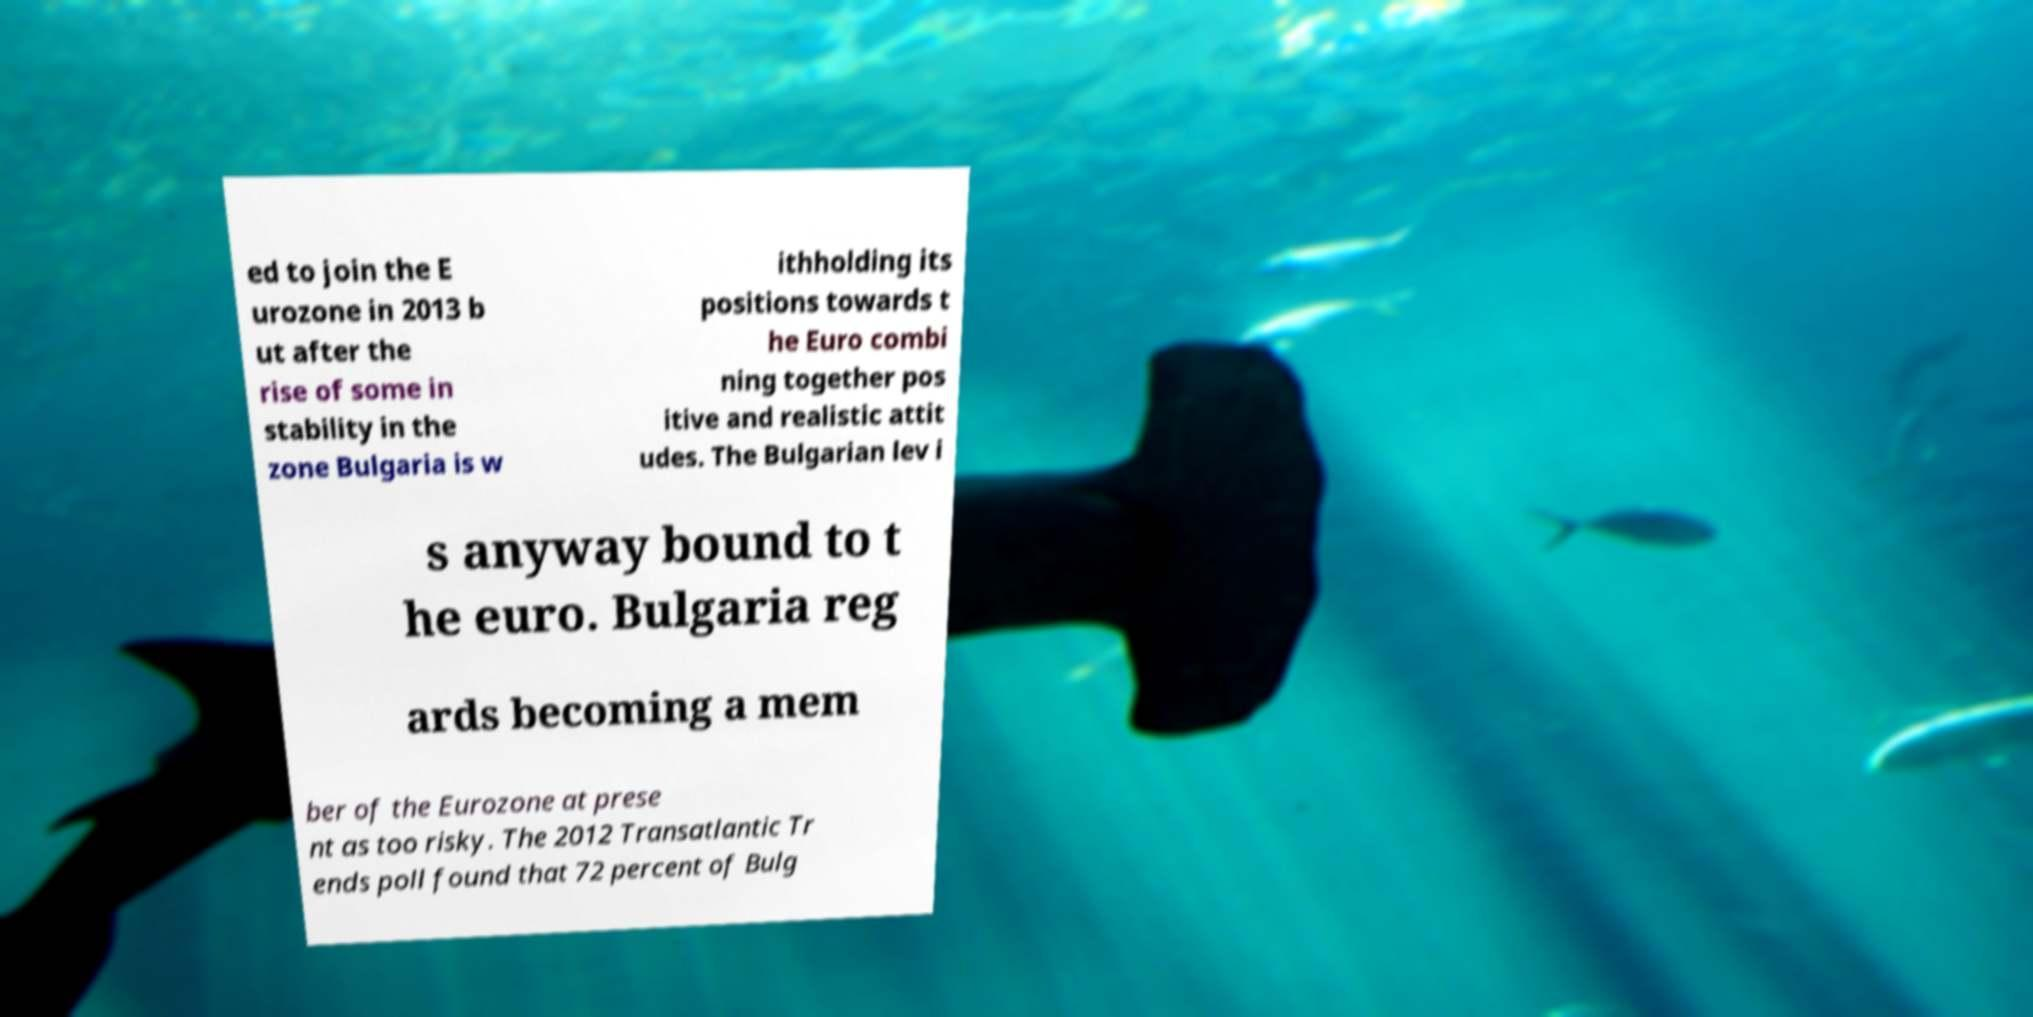Can you read and provide the text displayed in the image?This photo seems to have some interesting text. Can you extract and type it out for me? ed to join the E urozone in 2013 b ut after the rise of some in stability in the zone Bulgaria is w ithholding its positions towards t he Euro combi ning together pos itive and realistic attit udes. The Bulgarian lev i s anyway bound to t he euro. Bulgaria reg ards becoming a mem ber of the Eurozone at prese nt as too risky. The 2012 Transatlantic Tr ends poll found that 72 percent of Bulg 